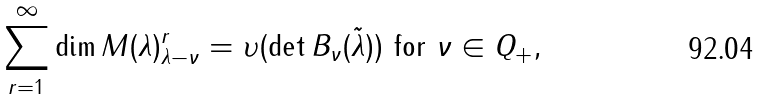Convert formula to latex. <formula><loc_0><loc_0><loc_500><loc_500>\sum _ { r = 1 } ^ { \infty } \dim M ( \lambda ) ^ { r } _ { \lambda - \nu } = \upsilon ( \det B _ { \nu } ( \tilde { \lambda } ) ) \text { for } \nu \in Q _ { + } ,</formula> 